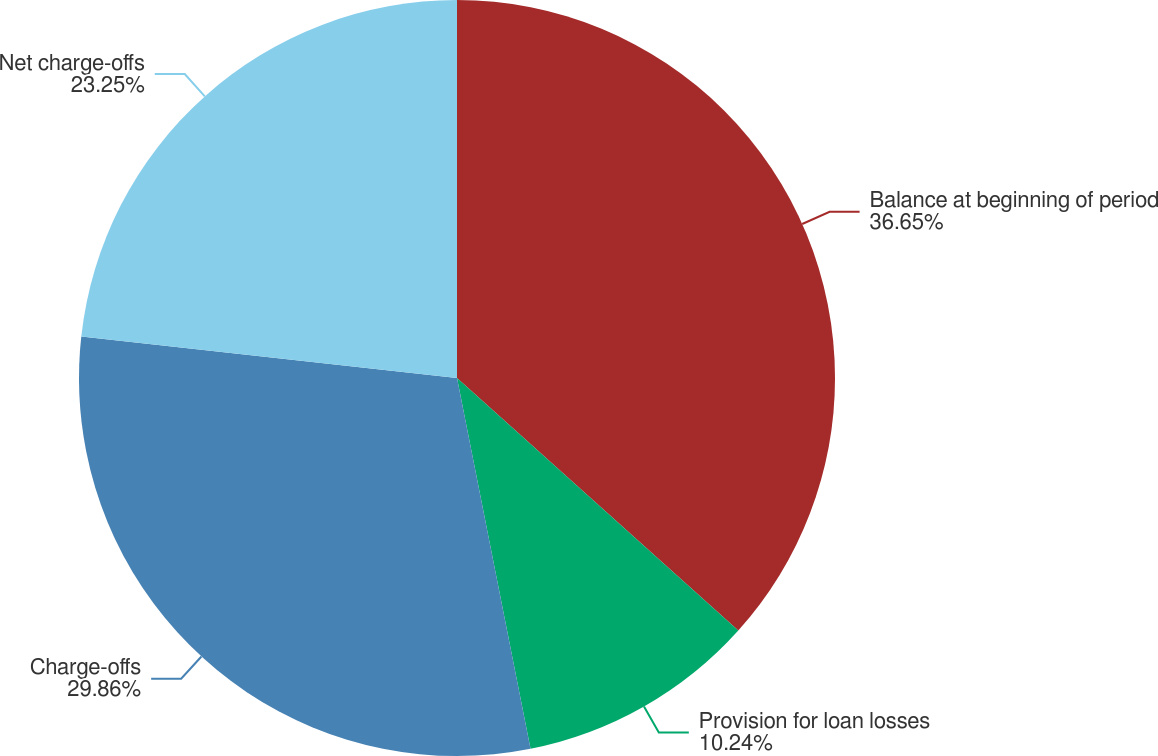<chart> <loc_0><loc_0><loc_500><loc_500><pie_chart><fcel>Balance at beginning of period<fcel>Provision for loan losses<fcel>Charge-offs<fcel>Net charge-offs<nl><fcel>36.64%<fcel>10.24%<fcel>29.86%<fcel>23.25%<nl></chart> 